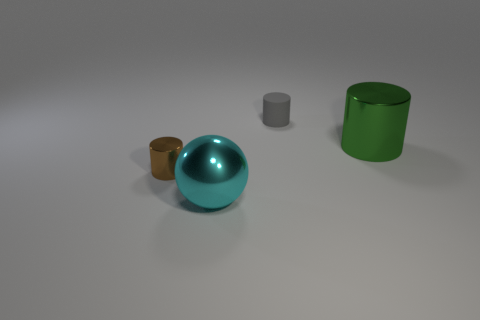Are there fewer small gray rubber cylinders than tiny metallic balls?
Ensure brevity in your answer.  No. What material is the thing that is both in front of the big green shiny thing and behind the big cyan ball?
Offer a very short reply. Metal. How big is the thing that is in front of the small cylinder in front of the large metal thing that is behind the brown thing?
Make the answer very short. Large. There is a tiny brown metallic thing; is its shape the same as the thing that is behind the green metal cylinder?
Offer a terse response. Yes. How many things are behind the large cyan sphere and left of the big shiny cylinder?
Offer a terse response. 2. What number of green objects are big cylinders or small matte cylinders?
Ensure brevity in your answer.  1. Does the small cylinder behind the brown metal object have the same color as the shiny cylinder in front of the big green cylinder?
Your answer should be very brief. No. What is the color of the metallic thing that is to the left of the large object that is left of the big thing that is on the right side of the ball?
Provide a succinct answer. Brown. Is there a big ball left of the cylinder that is in front of the big green thing?
Your response must be concise. No. There is a tiny thing that is on the left side of the big cyan shiny sphere; is its shape the same as the gray rubber object?
Keep it short and to the point. Yes. 